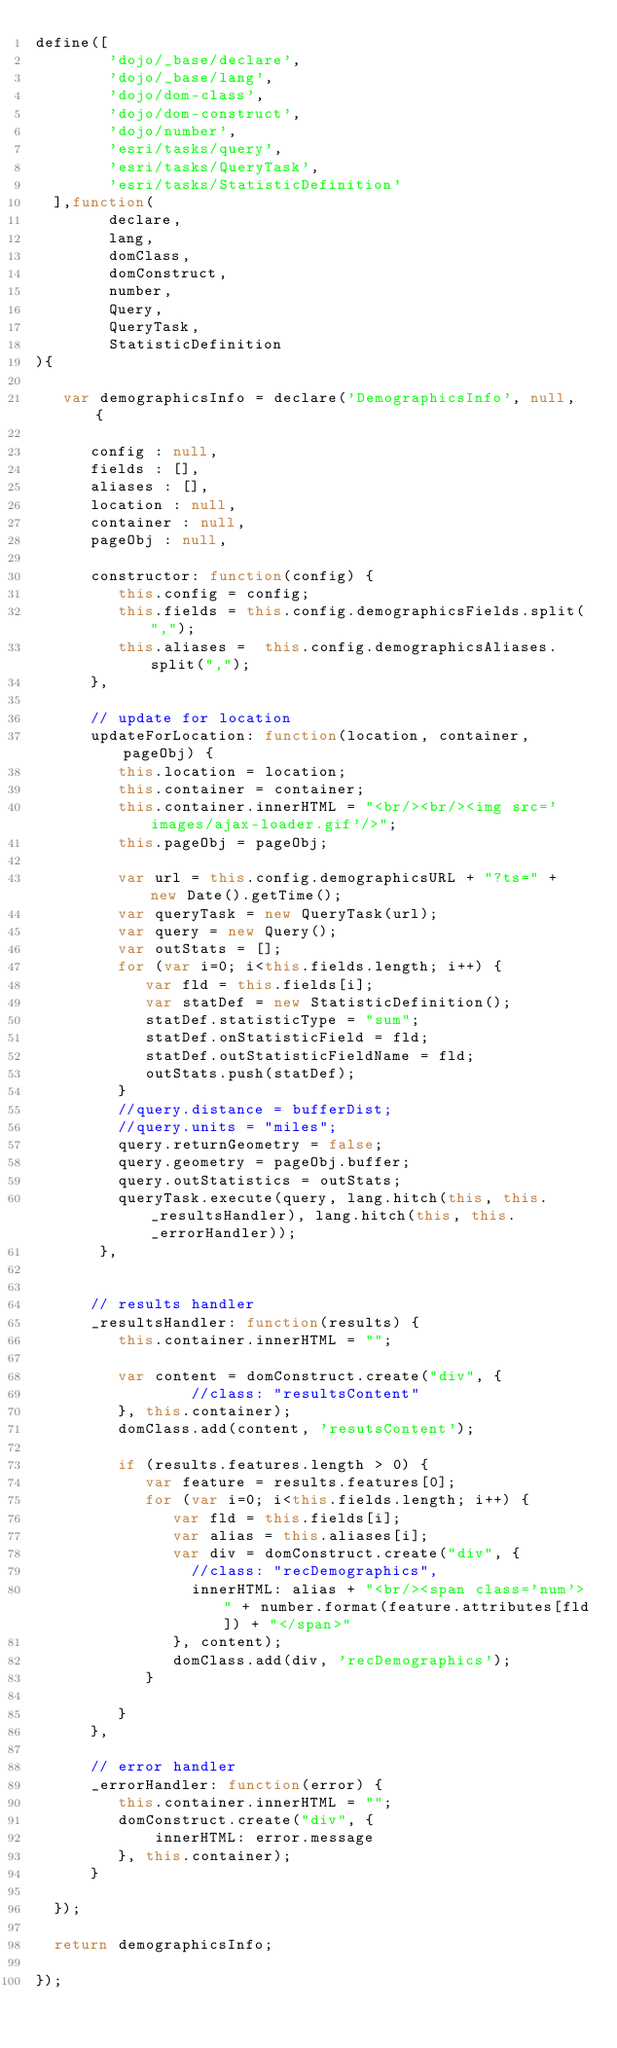<code> <loc_0><loc_0><loc_500><loc_500><_JavaScript_>define([
        'dojo/_base/declare',
        'dojo/_base/lang',
        'dojo/dom-class',
        'dojo/dom-construct',
        'dojo/number',
        'esri/tasks/query',
        'esri/tasks/QueryTask',
        'esri/tasks/StatisticDefinition'
	],function(
        declare, 
        lang, 
        domClass, 
        domConstruct, 
        number,
        Query,
        QueryTask,
        StatisticDefinition
){
		
   var demographicsInfo = declare('DemographicsInfo', null, {
       
      config : null,
      fields : [],
      aliases : [],
      location : null,
      container : null,
      pageObj : null,
	
      constructor: function(config) {
         this.config = config;
         this.fields = this.config.demographicsFields.split(",");
         this.aliases =  this.config.demographicsAliases.split(",");
      },
    		
      // update for location
      updateForLocation: function(location, container, pageObj) {
         this.location = location;
         this.container = container;
         this.container.innerHTML = "<br/><br/><img src='images/ajax-loader.gif'/>";
         this.pageObj = pageObj;
         
         var url = this.config.demographicsURL + "?ts=" + new Date().getTime();
         var queryTask = new QueryTask(url);
         var query = new Query();
         var outStats = [];
         for (var i=0; i<this.fields.length; i++) {
            var fld = this.fields[i];
            var statDef = new StatisticDefinition();
            statDef.statisticType = "sum";
            statDef.onStatisticField = fld;
            statDef.outStatisticFieldName = fld;
            outStats.push(statDef);
         }
         //query.distance = bufferDist;
         //query.units = "miles";
         query.returnGeometry = false;
         query.geometry = pageObj.buffer;
         query.outStatistics = outStats;
         queryTask.execute(query, lang.hitch(this, this._resultsHandler), lang.hitch(this, this._errorHandler));
       },
        	
    		    
      // results handler
      _resultsHandler: function(results) {
         this.container.innerHTML = "";
         
         var content = domConstruct.create("div", {
                 //class: "resultsContent"
         }, this.container);
         domClass.add(content, 'resutsContent');
             
         if (results.features.length > 0) {
            var feature = results.features[0];
            for (var i=0; i<this.fields.length; i++) {
               var fld = this.fields[i];
               var alias = this.aliases[i];
               var div = domConstruct.create("div", {
                 //class: "recDemographics",
                 innerHTML: alias + "<br/><span class='num'>" + number.format(feature.attributes[fld]) + "</span>"
               }, content);
               domClass.add(div, 'recDemographics');
            }
            
         }
      },
    
      // error handler
      _errorHandler: function(error) {
         this.container.innerHTML = "";
         domConstruct.create("div", {
             innerHTML: error.message
         }, this.container);
      }
		    
	});
	
	return demographicsInfo;
	
});</code> 